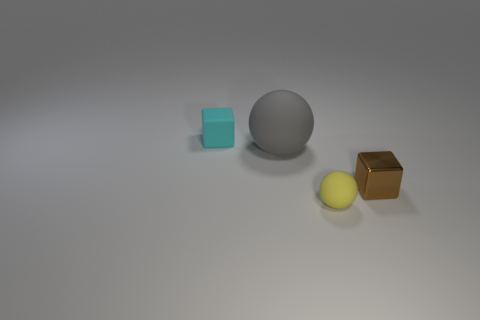Is there any other thing that is the same size as the gray matte thing?
Ensure brevity in your answer.  No. There is a cyan block that is made of the same material as the large object; what size is it?
Offer a terse response. Small. There is a small thing that is left of the small matte object to the right of the tiny cyan object; what is its shape?
Your answer should be very brief. Cube. How big is the rubber thing that is behind the yellow matte ball and on the right side of the cyan matte block?
Provide a short and direct response. Large. Are there any tiny gray objects that have the same shape as the large gray object?
Your response must be concise. No. Is there any other thing that has the same shape as the tiny cyan matte object?
Give a very brief answer. Yes. What is the material of the tiny yellow object in front of the small cube that is on the left side of the matte object in front of the brown block?
Offer a very short reply. Rubber. Is there a gray ball of the same size as the brown thing?
Offer a very short reply. No. The big object that is in front of the tiny thing behind the small brown metallic thing is what color?
Keep it short and to the point. Gray. How many yellow spheres are there?
Ensure brevity in your answer.  1. 